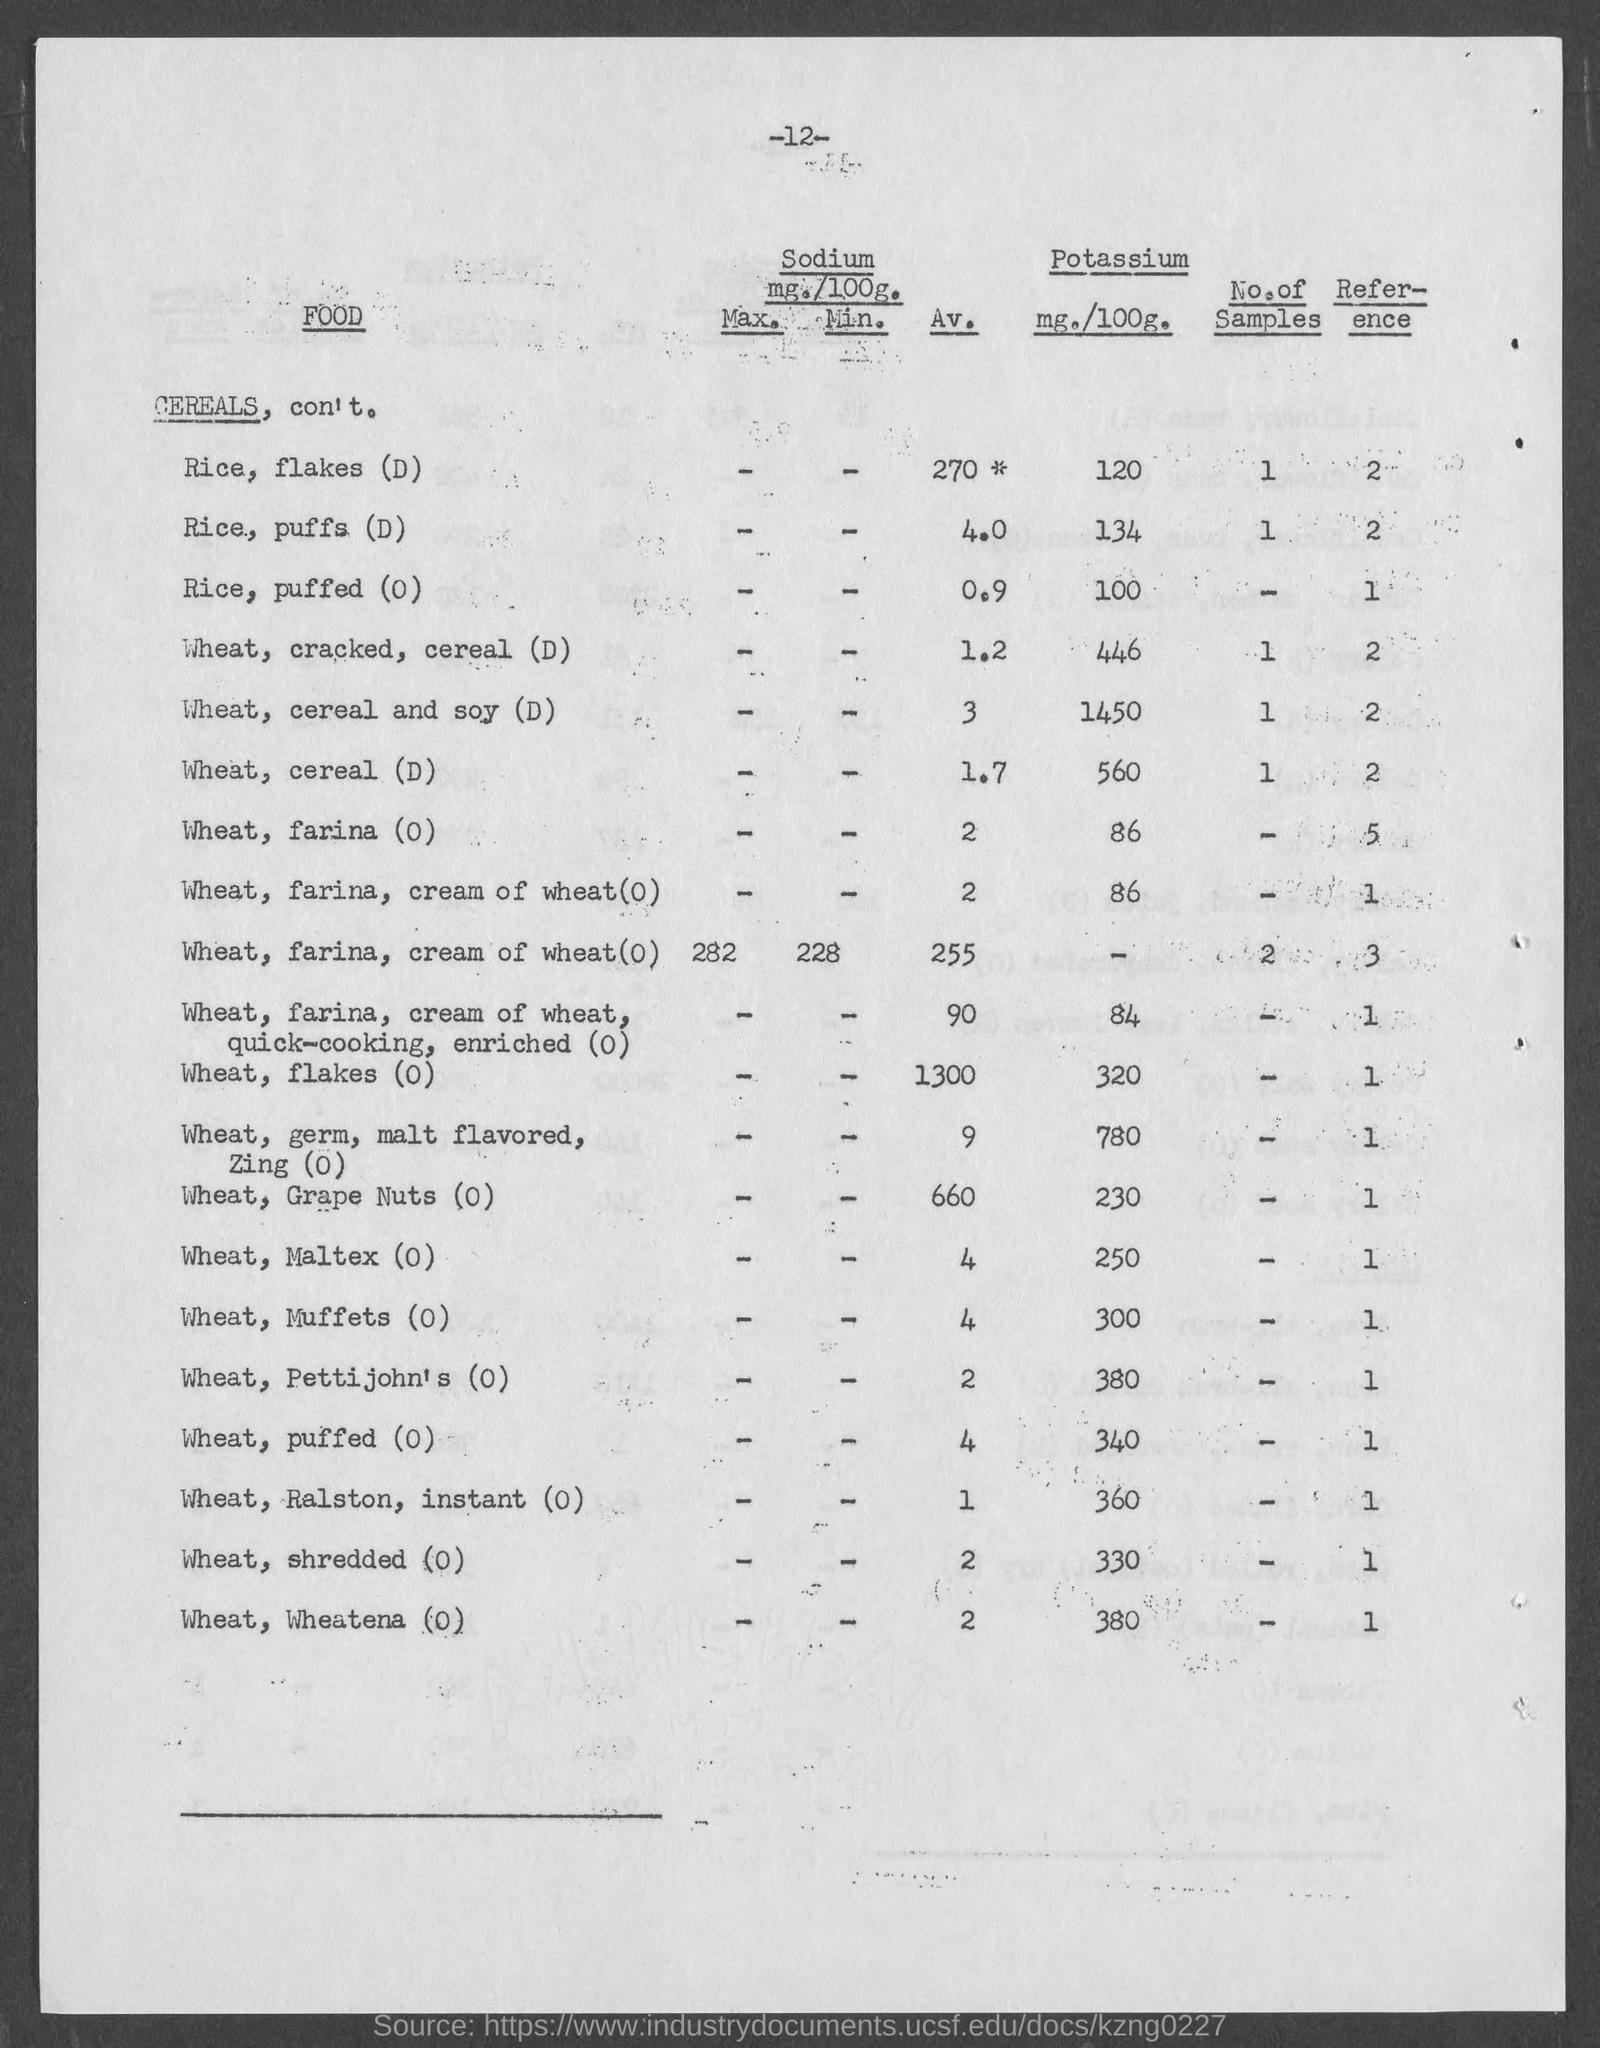Outline some significant characteristics in this image. The number at the top of the page is 12. The amount of potassium in 100 grams of Maltex (O) wheat is 250 milligrams. The amount of Potassium in 100 grams of wheat, cereal, and soy is 1450 milligrams. The amount of Potassium in 100 grams of wheat cereal (D) is 560 milligrams. In 100 grams of cracked, cereal wheat (D), there is 446 milligrams of potassium. 